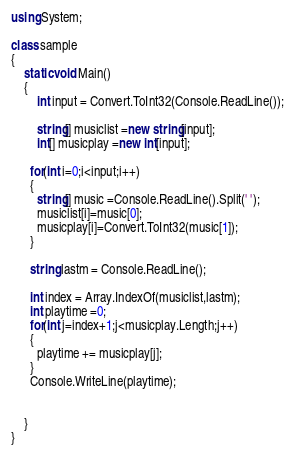<code> <loc_0><loc_0><loc_500><loc_500><_C#_>using System;

class sample
{
	static void Main()
	{
		int input = Convert.ToInt32(Console.ReadLine());
      
        string[] musiclist =new string[input];
        int[] musicplay =new int[input];
      
      for(int i=0;i<input;i++)
      {
        string[] music =Console.ReadLine().Split(' ');
        musiclist[i]=music[0];
        musicplay[i]=Convert.ToInt32(music[1]);
      }
      
      string lastm = Console.ReadLine();
      
      int index = Array.IndexOf(musiclist,lastm);
      int playtime =0;
      for(int j=index+1;j<musicplay.Length;j++)
      {
        playtime += musicplay[j];
      }
      Console.WriteLine(playtime);  
      
      
	}
}



</code> 